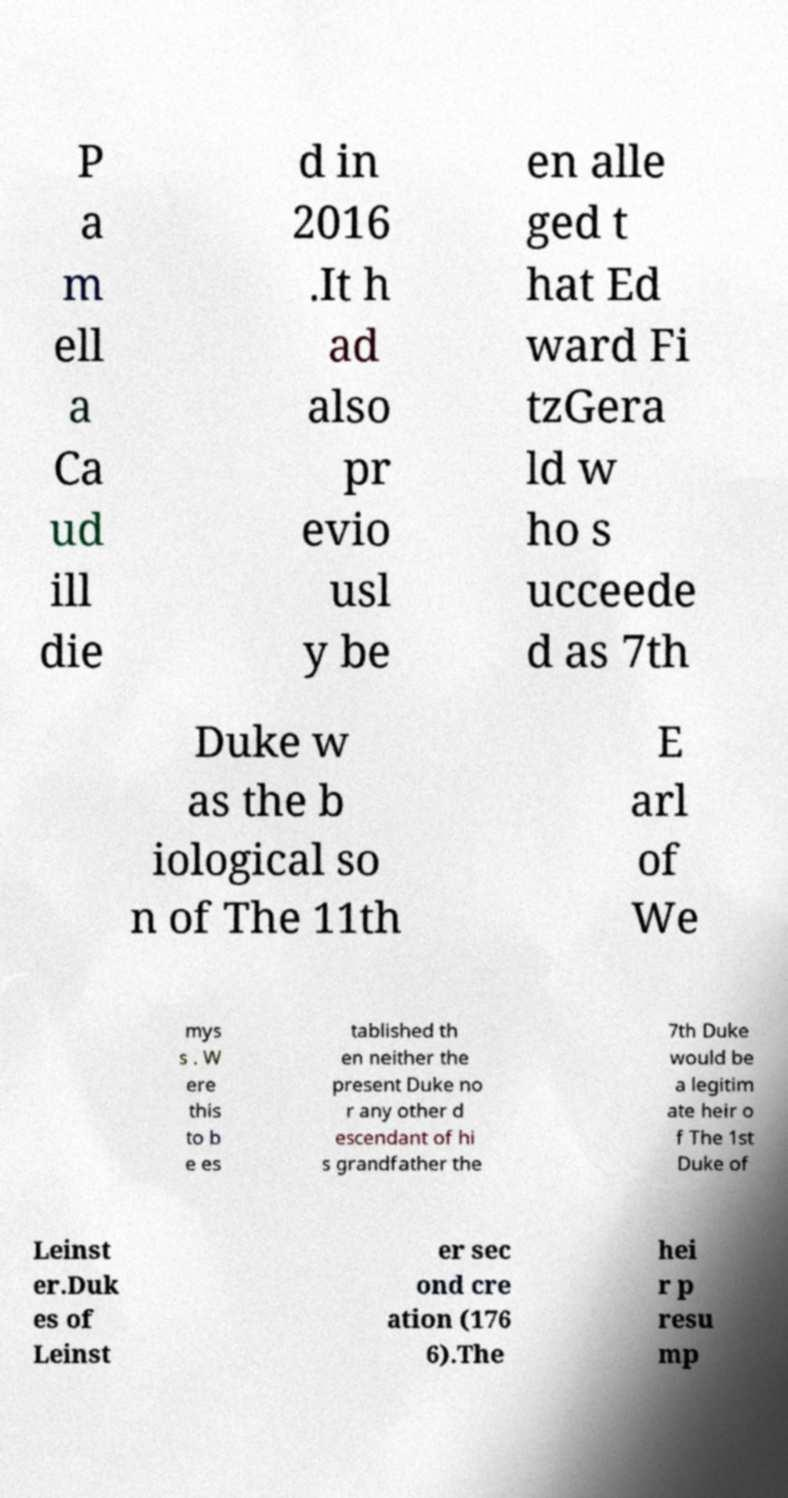I need the written content from this picture converted into text. Can you do that? P a m ell a Ca ud ill die d in 2016 .It h ad also pr evio usl y be en alle ged t hat Ed ward Fi tzGera ld w ho s ucceede d as 7th Duke w as the b iological so n of The 11th E arl of We mys s . W ere this to b e es tablished th en neither the present Duke no r any other d escendant of hi s grandfather the 7th Duke would be a legitim ate heir o f The 1st Duke of Leinst er.Duk es of Leinst er sec ond cre ation (176 6).The hei r p resu mp 